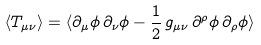<formula> <loc_0><loc_0><loc_500><loc_500>\langle T _ { \mu \nu } \rangle = \langle \partial _ { \mu } \phi \, \partial _ { \nu } \phi - \frac { 1 } { 2 } \, g _ { \mu \nu } \, \partial ^ { \rho } \phi \, \partial _ { \rho } \phi \rangle</formula> 